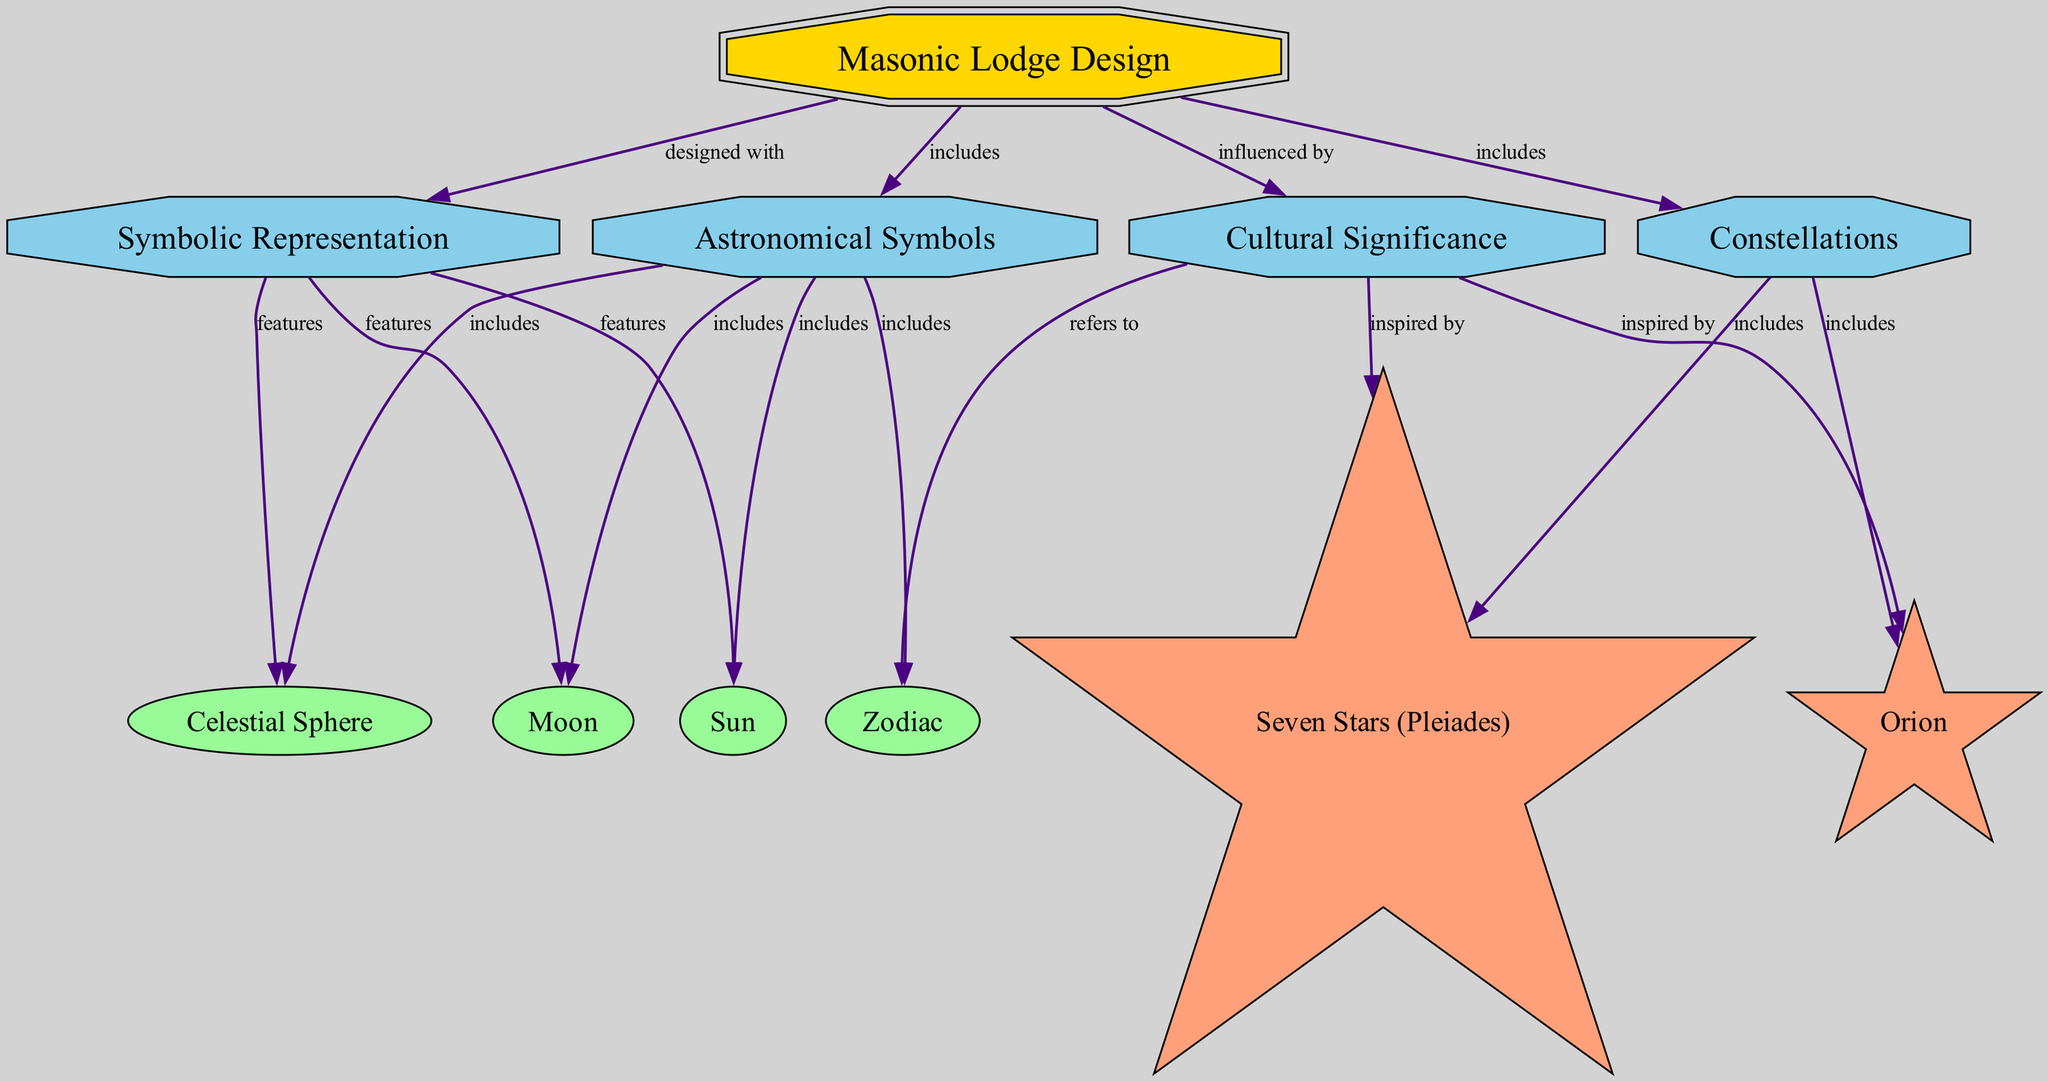What are the main topics included in the Masonic Lodge Design node? The diagram indicates that there are two main topics included in the Masonic Lodge Design node: Astronomical Symbols and Constellations. This is directly evident from the edges leading from the Masonic Lodge Design node to these two subtopics.
Answer: Astronomical Symbols, Constellations How many symbols are listed under Astronomical Symbols? Upon reviewing the Astronomical Symbols subtopic node, there are four symbols identified: Sun, Moon, Celestial Sphere, and Zodiac. Thus, the count of symbols is derived from the edges leading out from the subtopic node.
Answer: 4 Which constellation is inspired by Cultural Significance? The Cultural Significance subtopic has an arrow pointing to the Seven Stars (Pleiades) constellation. This indicates a direct relationship where the constellation is noted as being inspired by cultural importance.
Answer: Seven Stars (Pleiades) What types of nodes are connected to the Masonic Lodge Design node? The nodes that are connected to the Masonic Lodge Design node consist of subtopic nodes, a symbol node, and a constellation node. Specifically, these are Astronomical Symbols, Constellations, Symbolic Representation, and Cultural Significance, observed through direct edges from Masonic Lodge Design.
Answer: subtopic, symbol, constellation Which celestial body features in Symbolic Representation? The Symbolic Representation subtopic node displays connections to both the Sun and the Moon, indicating that these celestial bodies are included as features in this representation. Thus, the answer identifies specific connections within the diagram structure.
Answer: Sun, Moon How many constellations are part of the Constellations node? The Constellations subtopic has two distinct constellations attached to it: Seven Stars (Pleiades) and Orion. Thus, by examining the connections, we understand the count of the constellations linked within this node.
Answer: 2 Which symbols are included under the Astronomical Symbols node? From the edges leading from the Astronomical Symbols node, we see that four specific symbols are included: Sun, Moon, Celestial Sphere, and Zodiac. The answer requires an enumeration of the nodes connected to the subtopic.
Answer: Sun, Moon, Celestial Sphere, Zodiac What does Cultural Significance refer to within this diagram? According to the diagram, Cultural Significance refers to the Zodiac symbol. The edge points from the Cultural Significance subtopic directly to the Zodiac, indicating its relevance in the context of cultural importance in Masonic Lodge Designs.
Answer: Zodiac 